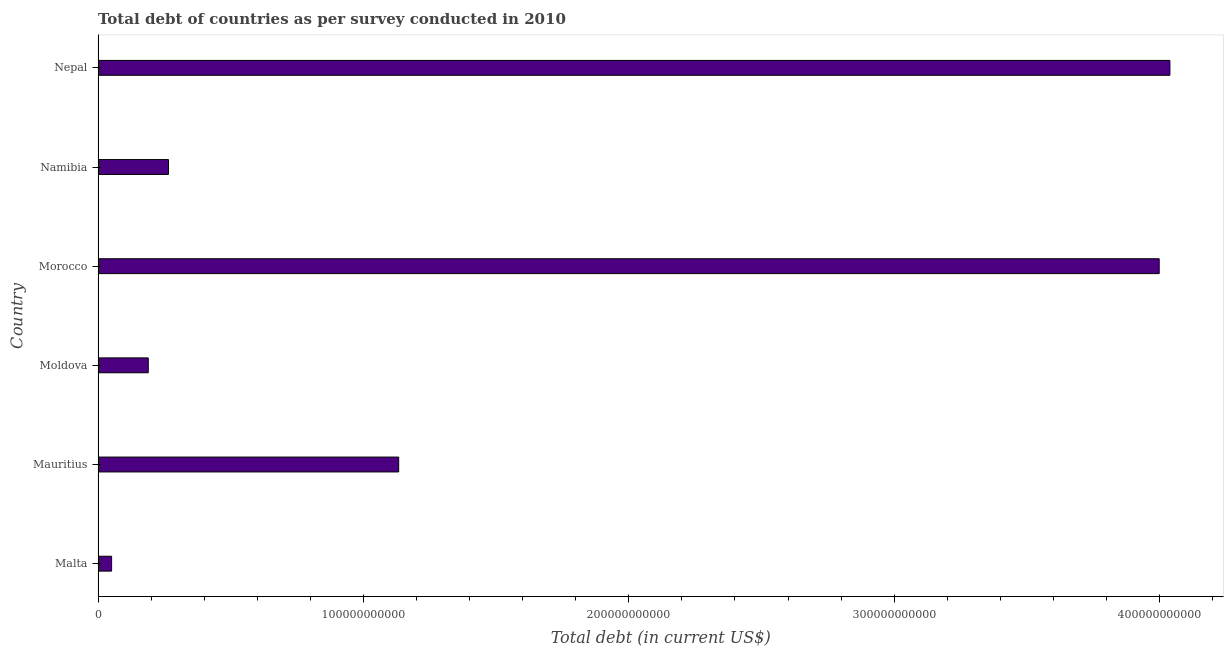What is the title of the graph?
Ensure brevity in your answer.  Total debt of countries as per survey conducted in 2010. What is the label or title of the X-axis?
Your answer should be compact. Total debt (in current US$). What is the label or title of the Y-axis?
Your response must be concise. Country. What is the total debt in Namibia?
Your answer should be very brief. 2.65e+1. Across all countries, what is the maximum total debt?
Your answer should be compact. 4.04e+11. Across all countries, what is the minimum total debt?
Ensure brevity in your answer.  5.11e+09. In which country was the total debt maximum?
Give a very brief answer. Nepal. In which country was the total debt minimum?
Provide a succinct answer. Malta. What is the sum of the total debt?
Make the answer very short. 9.68e+11. What is the difference between the total debt in Mauritius and Morocco?
Ensure brevity in your answer.  -2.87e+11. What is the average total debt per country?
Give a very brief answer. 1.61e+11. What is the median total debt?
Offer a terse response. 6.99e+1. What is the ratio of the total debt in Malta to that in Moldova?
Offer a terse response. 0.27. Is the total debt in Malta less than that in Mauritius?
Keep it short and to the point. Yes. What is the difference between the highest and the second highest total debt?
Ensure brevity in your answer.  4.04e+09. Is the sum of the total debt in Malta and Moldova greater than the maximum total debt across all countries?
Ensure brevity in your answer.  No. What is the difference between the highest and the lowest total debt?
Provide a short and direct response. 3.99e+11. In how many countries, is the total debt greater than the average total debt taken over all countries?
Offer a terse response. 2. How many bars are there?
Make the answer very short. 6. How many countries are there in the graph?
Your response must be concise. 6. What is the difference between two consecutive major ticks on the X-axis?
Offer a terse response. 1.00e+11. Are the values on the major ticks of X-axis written in scientific E-notation?
Give a very brief answer. No. What is the Total debt (in current US$) in Malta?
Your answer should be compact. 5.11e+09. What is the Total debt (in current US$) in Mauritius?
Your answer should be very brief. 1.13e+11. What is the Total debt (in current US$) of Moldova?
Give a very brief answer. 1.89e+1. What is the Total debt (in current US$) of Morocco?
Offer a terse response. 4.00e+11. What is the Total debt (in current US$) in Namibia?
Your response must be concise. 2.65e+1. What is the Total debt (in current US$) of Nepal?
Ensure brevity in your answer.  4.04e+11. What is the difference between the Total debt (in current US$) in Malta and Mauritius?
Make the answer very short. -1.08e+11. What is the difference between the Total debt (in current US$) in Malta and Moldova?
Your answer should be very brief. -1.38e+1. What is the difference between the Total debt (in current US$) in Malta and Morocco?
Your answer should be very brief. -3.95e+11. What is the difference between the Total debt (in current US$) in Malta and Namibia?
Offer a terse response. -2.14e+1. What is the difference between the Total debt (in current US$) in Malta and Nepal?
Ensure brevity in your answer.  -3.99e+11. What is the difference between the Total debt (in current US$) in Mauritius and Moldova?
Ensure brevity in your answer.  9.44e+1. What is the difference between the Total debt (in current US$) in Mauritius and Morocco?
Provide a succinct answer. -2.87e+11. What is the difference between the Total debt (in current US$) in Mauritius and Namibia?
Your response must be concise. 8.67e+1. What is the difference between the Total debt (in current US$) in Mauritius and Nepal?
Make the answer very short. -2.91e+11. What is the difference between the Total debt (in current US$) in Moldova and Morocco?
Offer a terse response. -3.81e+11. What is the difference between the Total debt (in current US$) in Moldova and Namibia?
Offer a very short reply. -7.62e+09. What is the difference between the Total debt (in current US$) in Moldova and Nepal?
Provide a succinct answer. -3.85e+11. What is the difference between the Total debt (in current US$) in Morocco and Namibia?
Make the answer very short. 3.73e+11. What is the difference between the Total debt (in current US$) in Morocco and Nepal?
Provide a short and direct response. -4.04e+09. What is the difference between the Total debt (in current US$) in Namibia and Nepal?
Your response must be concise. -3.77e+11. What is the ratio of the Total debt (in current US$) in Malta to that in Mauritius?
Provide a short and direct response. 0.04. What is the ratio of the Total debt (in current US$) in Malta to that in Moldova?
Offer a very short reply. 0.27. What is the ratio of the Total debt (in current US$) in Malta to that in Morocco?
Keep it short and to the point. 0.01. What is the ratio of the Total debt (in current US$) in Malta to that in Namibia?
Make the answer very short. 0.19. What is the ratio of the Total debt (in current US$) in Malta to that in Nepal?
Your answer should be compact. 0.01. What is the ratio of the Total debt (in current US$) in Mauritius to that in Moldova?
Ensure brevity in your answer.  5.99. What is the ratio of the Total debt (in current US$) in Mauritius to that in Morocco?
Ensure brevity in your answer.  0.28. What is the ratio of the Total debt (in current US$) in Mauritius to that in Namibia?
Give a very brief answer. 4.27. What is the ratio of the Total debt (in current US$) in Mauritius to that in Nepal?
Provide a succinct answer. 0.28. What is the ratio of the Total debt (in current US$) in Moldova to that in Morocco?
Ensure brevity in your answer.  0.05. What is the ratio of the Total debt (in current US$) in Moldova to that in Namibia?
Ensure brevity in your answer.  0.71. What is the ratio of the Total debt (in current US$) in Moldova to that in Nepal?
Provide a short and direct response. 0.05. What is the ratio of the Total debt (in current US$) in Morocco to that in Namibia?
Offer a terse response. 15.06. What is the ratio of the Total debt (in current US$) in Namibia to that in Nepal?
Your response must be concise. 0.07. 